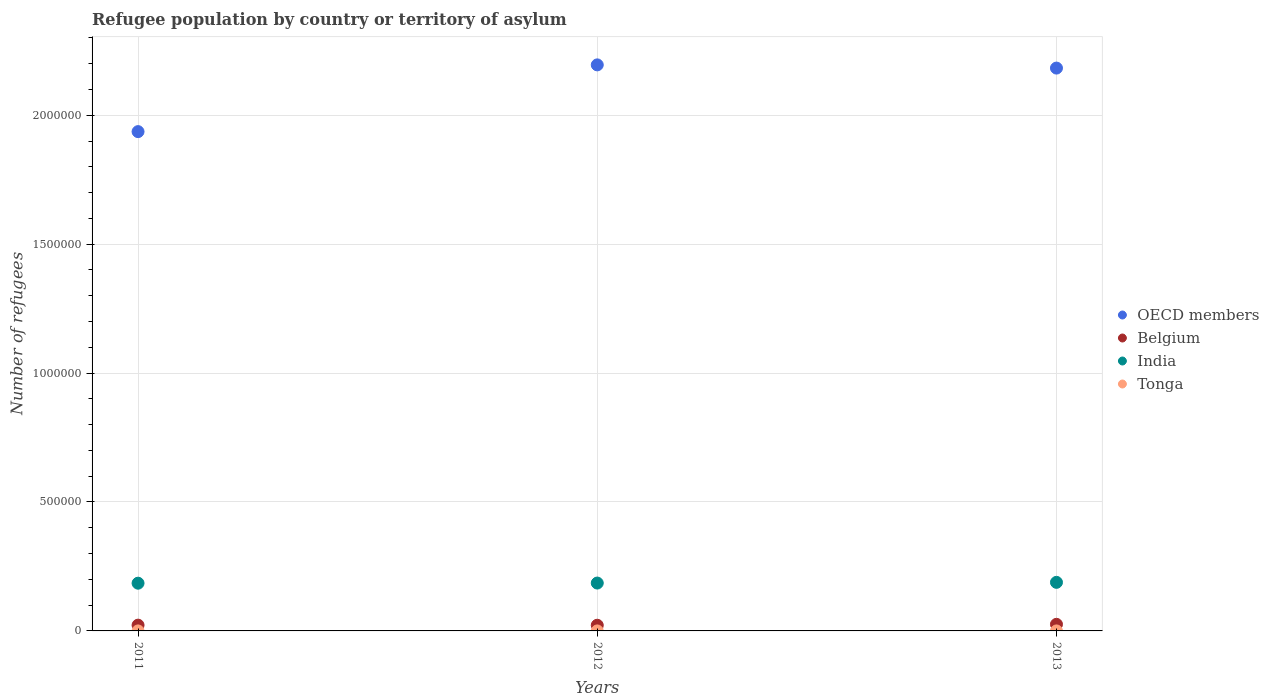Is the number of dotlines equal to the number of legend labels?
Your answer should be very brief. Yes. What is the number of refugees in India in 2012?
Your answer should be compact. 1.86e+05. Across all years, what is the maximum number of refugees in Belgium?
Your answer should be very brief. 2.56e+04. Across all years, what is the minimum number of refugees in OECD members?
Offer a terse response. 1.94e+06. What is the total number of refugees in India in the graph?
Make the answer very short. 5.59e+05. What is the difference between the number of refugees in Tonga in 2011 and that in 2013?
Keep it short and to the point. -1. What is the difference between the number of refugees in OECD members in 2011 and the number of refugees in Belgium in 2012?
Offer a very short reply. 1.91e+06. What is the average number of refugees in Belgium per year?
Offer a terse response. 2.34e+04. In the year 2013, what is the difference between the number of refugees in Tonga and number of refugees in India?
Your response must be concise. -1.88e+05. In how many years, is the number of refugees in Tonga greater than 900000?
Offer a terse response. 0. What is the ratio of the number of refugees in Belgium in 2011 to that in 2012?
Provide a short and direct response. 1.02. Is the difference between the number of refugees in Tonga in 2011 and 2012 greater than the difference between the number of refugees in India in 2011 and 2012?
Your response must be concise. Yes. What is the difference between the highest and the second highest number of refugees in Belgium?
Make the answer very short. 3231. What is the difference between the highest and the lowest number of refugees in OECD members?
Give a very brief answer. 2.59e+05. Is the sum of the number of refugees in India in 2011 and 2012 greater than the maximum number of refugees in Tonga across all years?
Ensure brevity in your answer.  Yes. Is it the case that in every year, the sum of the number of refugees in Tonga and number of refugees in OECD members  is greater than the sum of number of refugees in India and number of refugees in Belgium?
Give a very brief answer. Yes. Is it the case that in every year, the sum of the number of refugees in Tonga and number of refugees in Belgium  is greater than the number of refugees in India?
Offer a very short reply. No. Does the number of refugees in Tonga monotonically increase over the years?
Ensure brevity in your answer.  No. Is the number of refugees in Tonga strictly greater than the number of refugees in OECD members over the years?
Your answer should be very brief. No. How many dotlines are there?
Your response must be concise. 4. How many years are there in the graph?
Your response must be concise. 3. Are the values on the major ticks of Y-axis written in scientific E-notation?
Your answer should be very brief. No. Where does the legend appear in the graph?
Provide a succinct answer. Center right. How many legend labels are there?
Your answer should be very brief. 4. What is the title of the graph?
Your response must be concise. Refugee population by country or territory of asylum. Does "Europe(all income levels)" appear as one of the legend labels in the graph?
Ensure brevity in your answer.  No. What is the label or title of the Y-axis?
Offer a very short reply. Number of refugees. What is the Number of refugees in OECD members in 2011?
Offer a very short reply. 1.94e+06. What is the Number of refugees of Belgium in 2011?
Your answer should be very brief. 2.24e+04. What is the Number of refugees of India in 2011?
Your response must be concise. 1.85e+05. What is the Number of refugees of Tonga in 2011?
Your response must be concise. 2. What is the Number of refugees in OECD members in 2012?
Provide a short and direct response. 2.20e+06. What is the Number of refugees of Belgium in 2012?
Your response must be concise. 2.20e+04. What is the Number of refugees of India in 2012?
Provide a short and direct response. 1.86e+05. What is the Number of refugees in Tonga in 2012?
Provide a succinct answer. 3. What is the Number of refugees in OECD members in 2013?
Offer a very short reply. 2.18e+06. What is the Number of refugees of Belgium in 2013?
Offer a very short reply. 2.56e+04. What is the Number of refugees in India in 2013?
Offer a terse response. 1.88e+05. What is the Number of refugees of Tonga in 2013?
Your answer should be very brief. 3. Across all years, what is the maximum Number of refugees of OECD members?
Your response must be concise. 2.20e+06. Across all years, what is the maximum Number of refugees in Belgium?
Give a very brief answer. 2.56e+04. Across all years, what is the maximum Number of refugees in India?
Your response must be concise. 1.88e+05. Across all years, what is the maximum Number of refugees of Tonga?
Give a very brief answer. 3. Across all years, what is the minimum Number of refugees of OECD members?
Give a very brief answer. 1.94e+06. Across all years, what is the minimum Number of refugees in Belgium?
Offer a very short reply. 2.20e+04. Across all years, what is the minimum Number of refugees in India?
Ensure brevity in your answer.  1.85e+05. Across all years, what is the minimum Number of refugees of Tonga?
Your answer should be very brief. 2. What is the total Number of refugees in OECD members in the graph?
Your answer should be very brief. 6.31e+06. What is the total Number of refugees in Belgium in the graph?
Your answer should be very brief. 7.01e+04. What is the total Number of refugees of India in the graph?
Offer a terse response. 5.59e+05. What is the total Number of refugees of Tonga in the graph?
Give a very brief answer. 8. What is the difference between the Number of refugees in OECD members in 2011 and that in 2012?
Offer a terse response. -2.59e+05. What is the difference between the Number of refugees in Belgium in 2011 and that in 2012?
Give a very brief answer. 378. What is the difference between the Number of refugees in India in 2011 and that in 2012?
Your answer should be very brief. -538. What is the difference between the Number of refugees in OECD members in 2011 and that in 2013?
Ensure brevity in your answer.  -2.46e+05. What is the difference between the Number of refugees in Belgium in 2011 and that in 2013?
Offer a terse response. -3231. What is the difference between the Number of refugees in India in 2011 and that in 2013?
Offer a terse response. -3277. What is the difference between the Number of refugees in Tonga in 2011 and that in 2013?
Your answer should be compact. -1. What is the difference between the Number of refugees in OECD members in 2012 and that in 2013?
Offer a very short reply. 1.24e+04. What is the difference between the Number of refugees in Belgium in 2012 and that in 2013?
Offer a terse response. -3609. What is the difference between the Number of refugees in India in 2012 and that in 2013?
Your response must be concise. -2739. What is the difference between the Number of refugees of OECD members in 2011 and the Number of refugees of Belgium in 2012?
Offer a terse response. 1.91e+06. What is the difference between the Number of refugees of OECD members in 2011 and the Number of refugees of India in 2012?
Keep it short and to the point. 1.75e+06. What is the difference between the Number of refugees in OECD members in 2011 and the Number of refugees in Tonga in 2012?
Keep it short and to the point. 1.94e+06. What is the difference between the Number of refugees of Belgium in 2011 and the Number of refugees of India in 2012?
Offer a terse response. -1.63e+05. What is the difference between the Number of refugees of Belgium in 2011 and the Number of refugees of Tonga in 2012?
Your response must be concise. 2.24e+04. What is the difference between the Number of refugees of India in 2011 and the Number of refugees of Tonga in 2012?
Keep it short and to the point. 1.85e+05. What is the difference between the Number of refugees in OECD members in 2011 and the Number of refugees in Belgium in 2013?
Offer a terse response. 1.91e+06. What is the difference between the Number of refugees of OECD members in 2011 and the Number of refugees of India in 2013?
Make the answer very short. 1.75e+06. What is the difference between the Number of refugees in OECD members in 2011 and the Number of refugees in Tonga in 2013?
Offer a terse response. 1.94e+06. What is the difference between the Number of refugees of Belgium in 2011 and the Number of refugees of India in 2013?
Offer a very short reply. -1.66e+05. What is the difference between the Number of refugees in Belgium in 2011 and the Number of refugees in Tonga in 2013?
Your response must be concise. 2.24e+04. What is the difference between the Number of refugees of India in 2011 and the Number of refugees of Tonga in 2013?
Your response must be concise. 1.85e+05. What is the difference between the Number of refugees of OECD members in 2012 and the Number of refugees of Belgium in 2013?
Your answer should be very brief. 2.17e+06. What is the difference between the Number of refugees in OECD members in 2012 and the Number of refugees in India in 2013?
Give a very brief answer. 2.01e+06. What is the difference between the Number of refugees of OECD members in 2012 and the Number of refugees of Tonga in 2013?
Offer a terse response. 2.20e+06. What is the difference between the Number of refugees in Belgium in 2012 and the Number of refugees in India in 2013?
Offer a very short reply. -1.66e+05. What is the difference between the Number of refugees of Belgium in 2012 and the Number of refugees of Tonga in 2013?
Ensure brevity in your answer.  2.20e+04. What is the difference between the Number of refugees in India in 2012 and the Number of refugees in Tonga in 2013?
Give a very brief answer. 1.86e+05. What is the average Number of refugees in OECD members per year?
Your response must be concise. 2.10e+06. What is the average Number of refugees of Belgium per year?
Make the answer very short. 2.34e+04. What is the average Number of refugees of India per year?
Make the answer very short. 1.86e+05. What is the average Number of refugees in Tonga per year?
Provide a short and direct response. 2.67. In the year 2011, what is the difference between the Number of refugees of OECD members and Number of refugees of Belgium?
Your answer should be very brief. 1.91e+06. In the year 2011, what is the difference between the Number of refugees in OECD members and Number of refugees in India?
Keep it short and to the point. 1.75e+06. In the year 2011, what is the difference between the Number of refugees in OECD members and Number of refugees in Tonga?
Offer a terse response. 1.94e+06. In the year 2011, what is the difference between the Number of refugees of Belgium and Number of refugees of India?
Keep it short and to the point. -1.63e+05. In the year 2011, what is the difference between the Number of refugees in Belgium and Number of refugees in Tonga?
Offer a very short reply. 2.24e+04. In the year 2011, what is the difference between the Number of refugees in India and Number of refugees in Tonga?
Give a very brief answer. 1.85e+05. In the year 2012, what is the difference between the Number of refugees of OECD members and Number of refugees of Belgium?
Your answer should be very brief. 2.17e+06. In the year 2012, what is the difference between the Number of refugees of OECD members and Number of refugees of India?
Make the answer very short. 2.01e+06. In the year 2012, what is the difference between the Number of refugees of OECD members and Number of refugees of Tonga?
Offer a terse response. 2.20e+06. In the year 2012, what is the difference between the Number of refugees in Belgium and Number of refugees in India?
Your response must be concise. -1.64e+05. In the year 2012, what is the difference between the Number of refugees in Belgium and Number of refugees in Tonga?
Provide a short and direct response. 2.20e+04. In the year 2012, what is the difference between the Number of refugees in India and Number of refugees in Tonga?
Your answer should be very brief. 1.86e+05. In the year 2013, what is the difference between the Number of refugees of OECD members and Number of refugees of Belgium?
Your response must be concise. 2.16e+06. In the year 2013, what is the difference between the Number of refugees in OECD members and Number of refugees in India?
Offer a terse response. 1.99e+06. In the year 2013, what is the difference between the Number of refugees of OECD members and Number of refugees of Tonga?
Your answer should be very brief. 2.18e+06. In the year 2013, what is the difference between the Number of refugees of Belgium and Number of refugees of India?
Give a very brief answer. -1.63e+05. In the year 2013, what is the difference between the Number of refugees of Belgium and Number of refugees of Tonga?
Ensure brevity in your answer.  2.56e+04. In the year 2013, what is the difference between the Number of refugees in India and Number of refugees in Tonga?
Your response must be concise. 1.88e+05. What is the ratio of the Number of refugees of OECD members in 2011 to that in 2012?
Make the answer very short. 0.88. What is the ratio of the Number of refugees in Belgium in 2011 to that in 2012?
Your answer should be very brief. 1.02. What is the ratio of the Number of refugees of OECD members in 2011 to that in 2013?
Your response must be concise. 0.89. What is the ratio of the Number of refugees in Belgium in 2011 to that in 2013?
Provide a short and direct response. 0.87. What is the ratio of the Number of refugees of India in 2011 to that in 2013?
Offer a very short reply. 0.98. What is the ratio of the Number of refugees in Tonga in 2011 to that in 2013?
Keep it short and to the point. 0.67. What is the ratio of the Number of refugees in Belgium in 2012 to that in 2013?
Your response must be concise. 0.86. What is the ratio of the Number of refugees in India in 2012 to that in 2013?
Your response must be concise. 0.99. What is the difference between the highest and the second highest Number of refugees of OECD members?
Make the answer very short. 1.24e+04. What is the difference between the highest and the second highest Number of refugees in Belgium?
Ensure brevity in your answer.  3231. What is the difference between the highest and the second highest Number of refugees of India?
Your answer should be very brief. 2739. What is the difference between the highest and the second highest Number of refugees of Tonga?
Offer a terse response. 0. What is the difference between the highest and the lowest Number of refugees in OECD members?
Your answer should be very brief. 2.59e+05. What is the difference between the highest and the lowest Number of refugees of Belgium?
Offer a terse response. 3609. What is the difference between the highest and the lowest Number of refugees in India?
Give a very brief answer. 3277. 